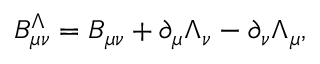<formula> <loc_0><loc_0><loc_500><loc_500>B _ { \mu \nu } ^ { \Lambda } = B _ { \mu \nu } + \partial _ { \mu } \Lambda _ { \nu } - \partial _ { \nu } \Lambda _ { \mu } ,</formula> 